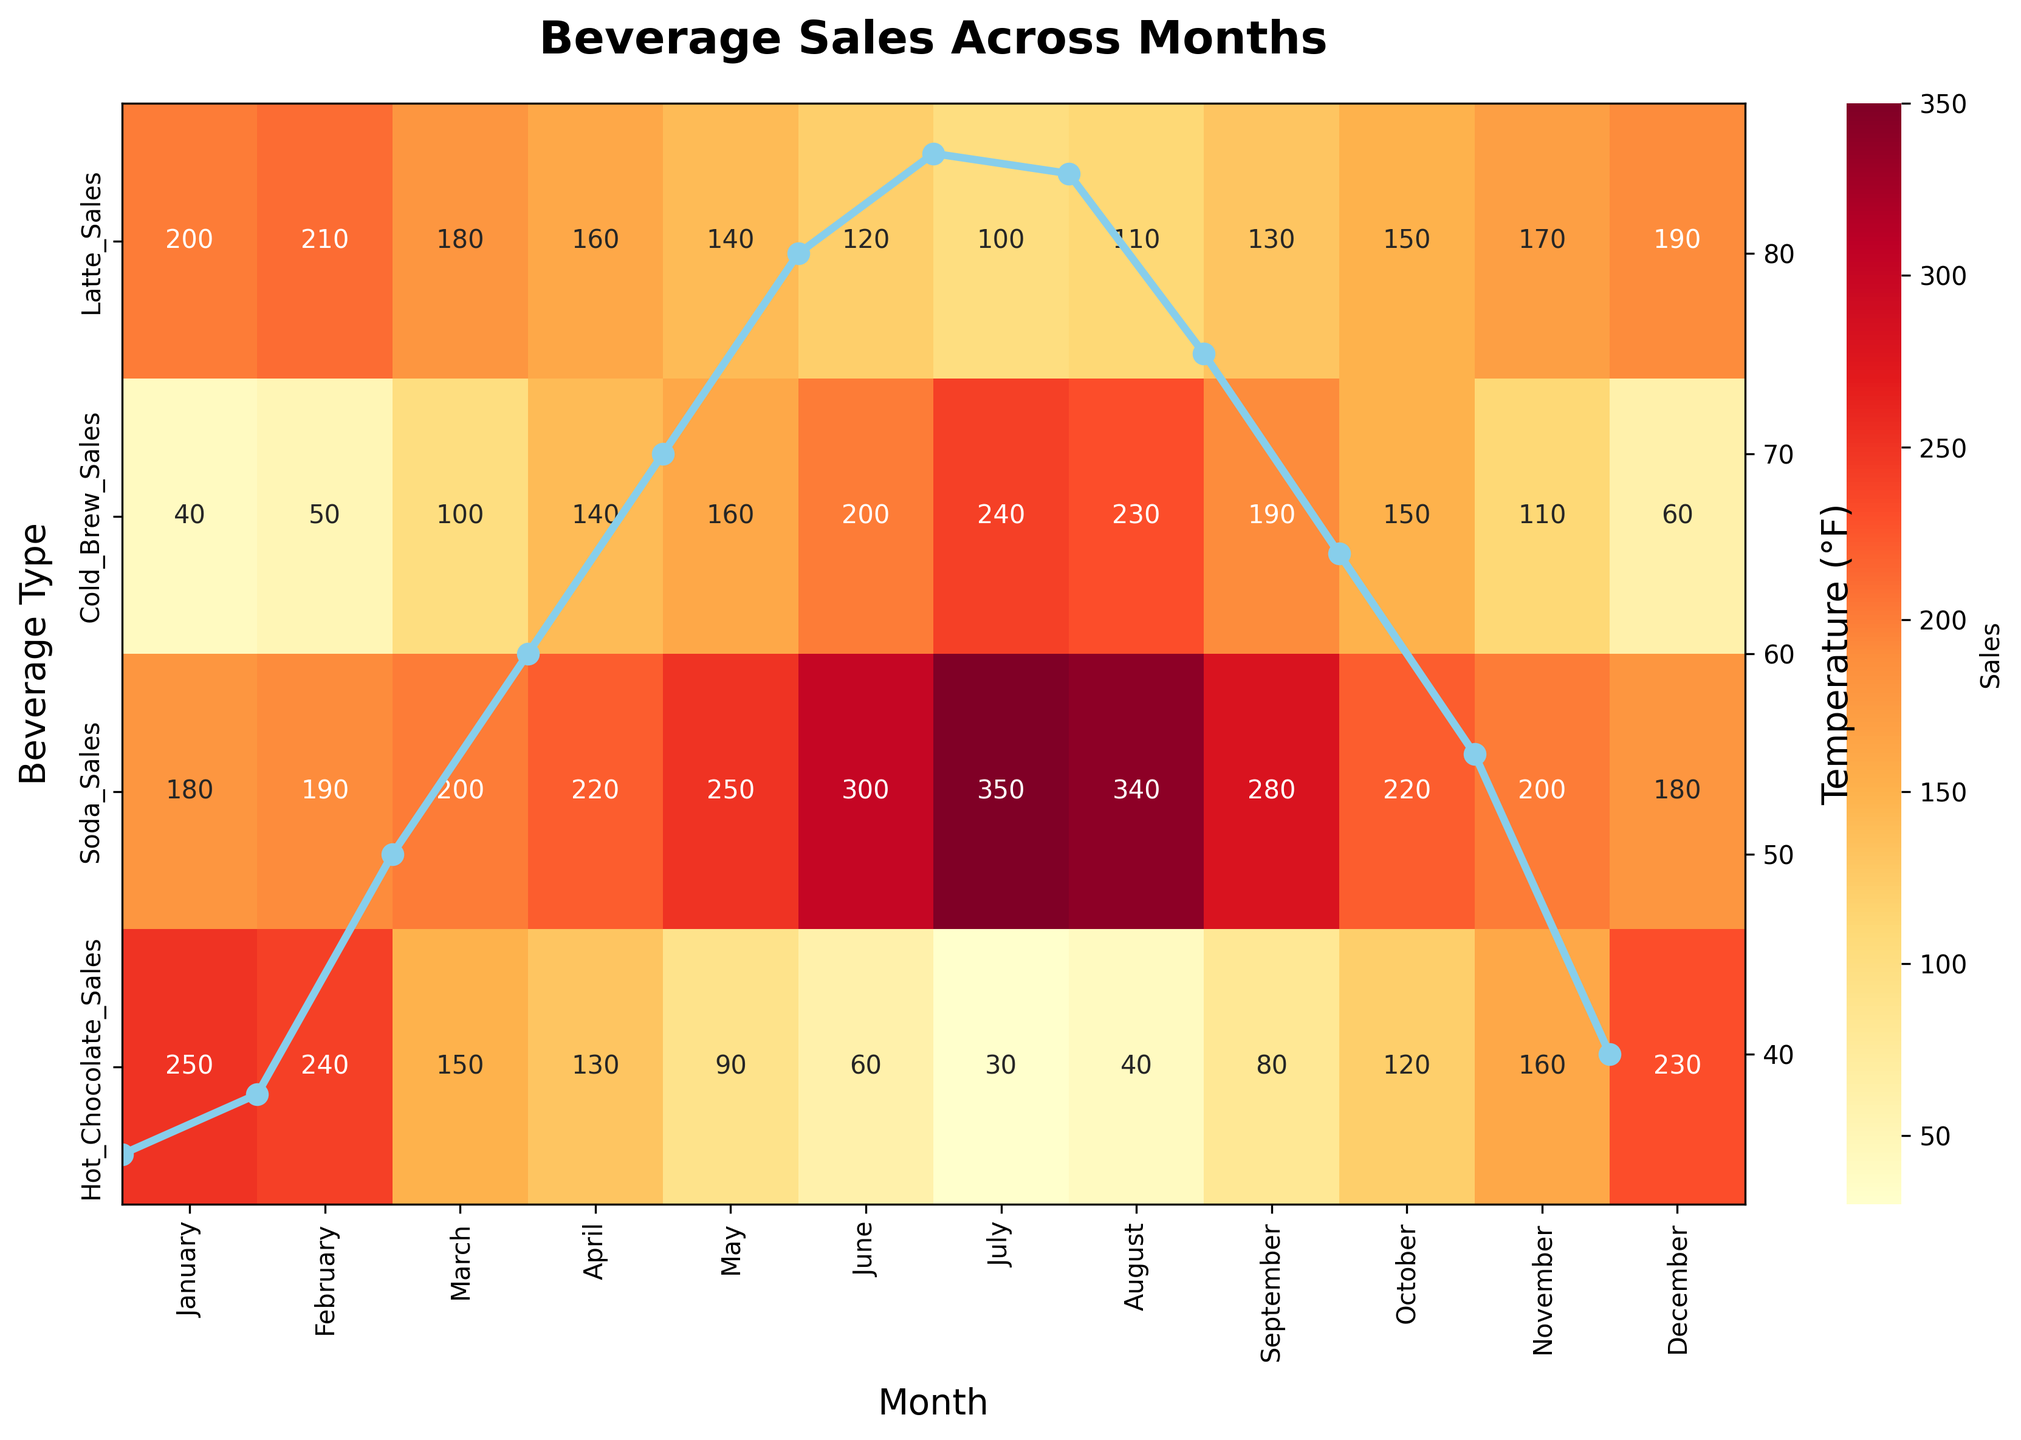What is the title of the figure? To find the title of the figure, look at the top of the plot where the title text is displayed. In this figure, the title summarizes the information presented in the heatmap.
Answer: Beverage Sales Across Months Which month has the highest sales for Cold Brew? Look at the row corresponding to 'Cold Brew Sales' on the heatmap and identify the highest value. Then, check the column label for that value to find the month.
Answer: July By how much do Soda sales in June exceed those in January? Locate the Soda sales in both June and January by referring to the respective cells in the 'Soda_Sales' row of the heatmap. Subtract the January value from the June value.
Answer: 300 - 180 = 120 What types of beverages are shown in the heatmap? Refer to the y-axis labels on the heatmap, which indicate the different beverages that have their sales data plotted.
Answer: Latte, Cold Brew, Soda, Hot Chocolate In which month is the temperature plotted the highest? Look at the line plot overlaid on the heatmap representing temperature data. Identify the peak point on this line and note the corresponding month.
Answer: July How do Hot Chocolate sales in December compare to those in August? Compare the value for Hot Chocolate in December against the value in August by looking at their respective cells in the 'Hot_Chocolate_Sales' row. State which value is greater.
Answer: December: 230, August: 40. December sales are higher by 190 Which beverage shows the highest sales in May? Observe the May column in the heatmap and identify which row shows the highest value, indicating the beverage that sold the most in that month.
Answer: Soda Calculate the average sales of Latte over the entire year. Sum the sales of Latte from January to December by checking each value in the 'Latte_Sales' row of the heatmap, then divide by the number of months (12).
Answer: (200+210+180+160+140+120+100+110+130+150+170+190) / 12 = 155 In which season are Hot Chocolate sales generally the highest? Identify which temperature category (Cold, Cool, Warm, Hot) generally has higher values for Hot Chocolate sales by comparing sales in rows and columns grouped by seasons (Winter: Dec-Feb, Spring: Mar-May, Summer: Jun-Aug, Fall: Sep-Nov).
Answer: Winter Do Cold Brew sales consistently increase with temperature? Examine the Cold Brew sales row and compare the sales values with the temperature values plotted above. Note the pattern of sales as the temperatures rise.
Answer: Yes 